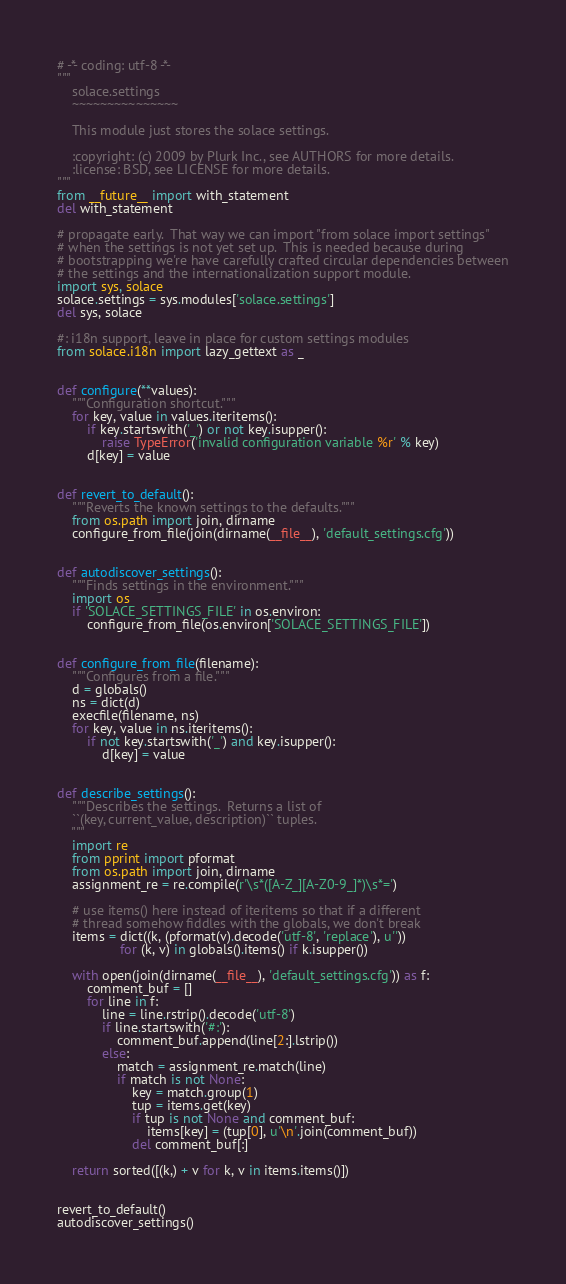<code> <loc_0><loc_0><loc_500><loc_500><_Python_># -*- coding: utf-8 -*-
"""
    solace.settings
    ~~~~~~~~~~~~~~~

    This module just stores the solace settings.

    :copyright: (c) 2009 by Plurk Inc., see AUTHORS for more details.
    :license: BSD, see LICENSE for more details.
"""
from __future__ import with_statement
del with_statement

# propagate early.  That way we can import "from solace import settings"
# when the settings is not yet set up.  This is needed because during
# bootstrapping we're have carefully crafted circular dependencies between
# the settings and the internationalization support module.
import sys, solace
solace.settings = sys.modules['solace.settings']
del sys, solace

#: i18n support, leave in place for custom settings modules
from solace.i18n import lazy_gettext as _


def configure(**values):
    """Configuration shortcut."""
    for key, value in values.iteritems():
        if key.startswith('_') or not key.isupper():
            raise TypeError('invalid configuration variable %r' % key)
        d[key] = value


def revert_to_default():
    """Reverts the known settings to the defaults."""
    from os.path import join, dirname
    configure_from_file(join(dirname(__file__), 'default_settings.cfg'))


def autodiscover_settings():
    """Finds settings in the environment."""
    import os
    if 'SOLACE_SETTINGS_FILE' in os.environ:
        configure_from_file(os.environ['SOLACE_SETTINGS_FILE'])


def configure_from_file(filename):
    """Configures from a file."""
    d = globals()
    ns = dict(d)
    execfile(filename, ns)
    for key, value in ns.iteritems():
        if not key.startswith('_') and key.isupper():
            d[key] = value


def describe_settings():
    """Describes the settings.  Returns a list of
    ``(key, current_value, description)`` tuples.
    """
    import re
    from pprint import pformat
    from os.path import join, dirname
    assignment_re = re.compile(r'\s*([A-Z_][A-Z0-9_]*)\s*=')

    # use items() here instead of iteritems so that if a different
    # thread somehow fiddles with the globals, we don't break
    items = dict((k, (pformat(v).decode('utf-8', 'replace'), u''))
                 for (k, v) in globals().items() if k.isupper())

    with open(join(dirname(__file__), 'default_settings.cfg')) as f:
        comment_buf = []
        for line in f:
            line = line.rstrip().decode('utf-8')
            if line.startswith('#:'):
                comment_buf.append(line[2:].lstrip())
            else:
                match = assignment_re.match(line)
                if match is not None:
                    key = match.group(1)
                    tup = items.get(key)
                    if tup is not None and comment_buf:
                        items[key] = (tup[0], u'\n'.join(comment_buf))
                    del comment_buf[:]

    return sorted([(k,) + v for k, v in items.items()])


revert_to_default()
autodiscover_settings()
</code> 